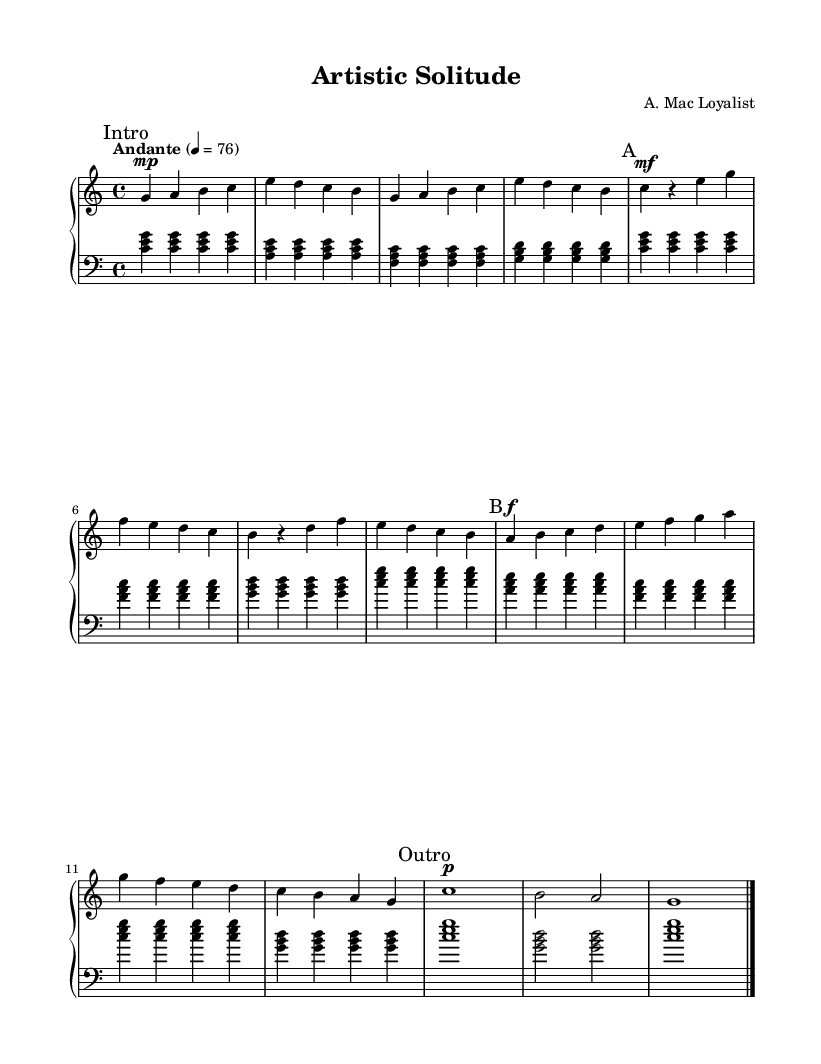What is the key signature of this music? The key signature is indicated at the beginning of the score, which shows there are no sharps or flats, indicating the key of C major.
Answer: C major What is the time signature of this piece? The time signature is displayed at the start of the score, which shows 4 over 4, meaning there are four beats in each measure.
Answer: 4/4 What is the tempo marking of this score? The tempo is marked as "Andante" with a metronome marking of 76, indicating a moderate pace.
Answer: Andante, 76 How many measures are there in section A? By counting the measures in the section marked "A," there are a total of four measures in this section.
Answer: 4 What is the dynamic marking for the B section? The dynamic marking in the B section indicates forte, which is represented by the symbol "f," denoting a loud volume.
Answer: Forte What is the last note played in the piece? The last note displayed at the end of the score is a G note, played as a whole note in the final measure.
Answer: G Which sections are present in this score? The score consists of four sections, identified as Intro, A, B, and Outro, each marked accordingly in the music.
Answer: Intro, A, B, Outro 